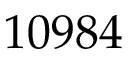Convert formula to latex. <formula><loc_0><loc_0><loc_500><loc_500>1 0 9 8 4</formula> 